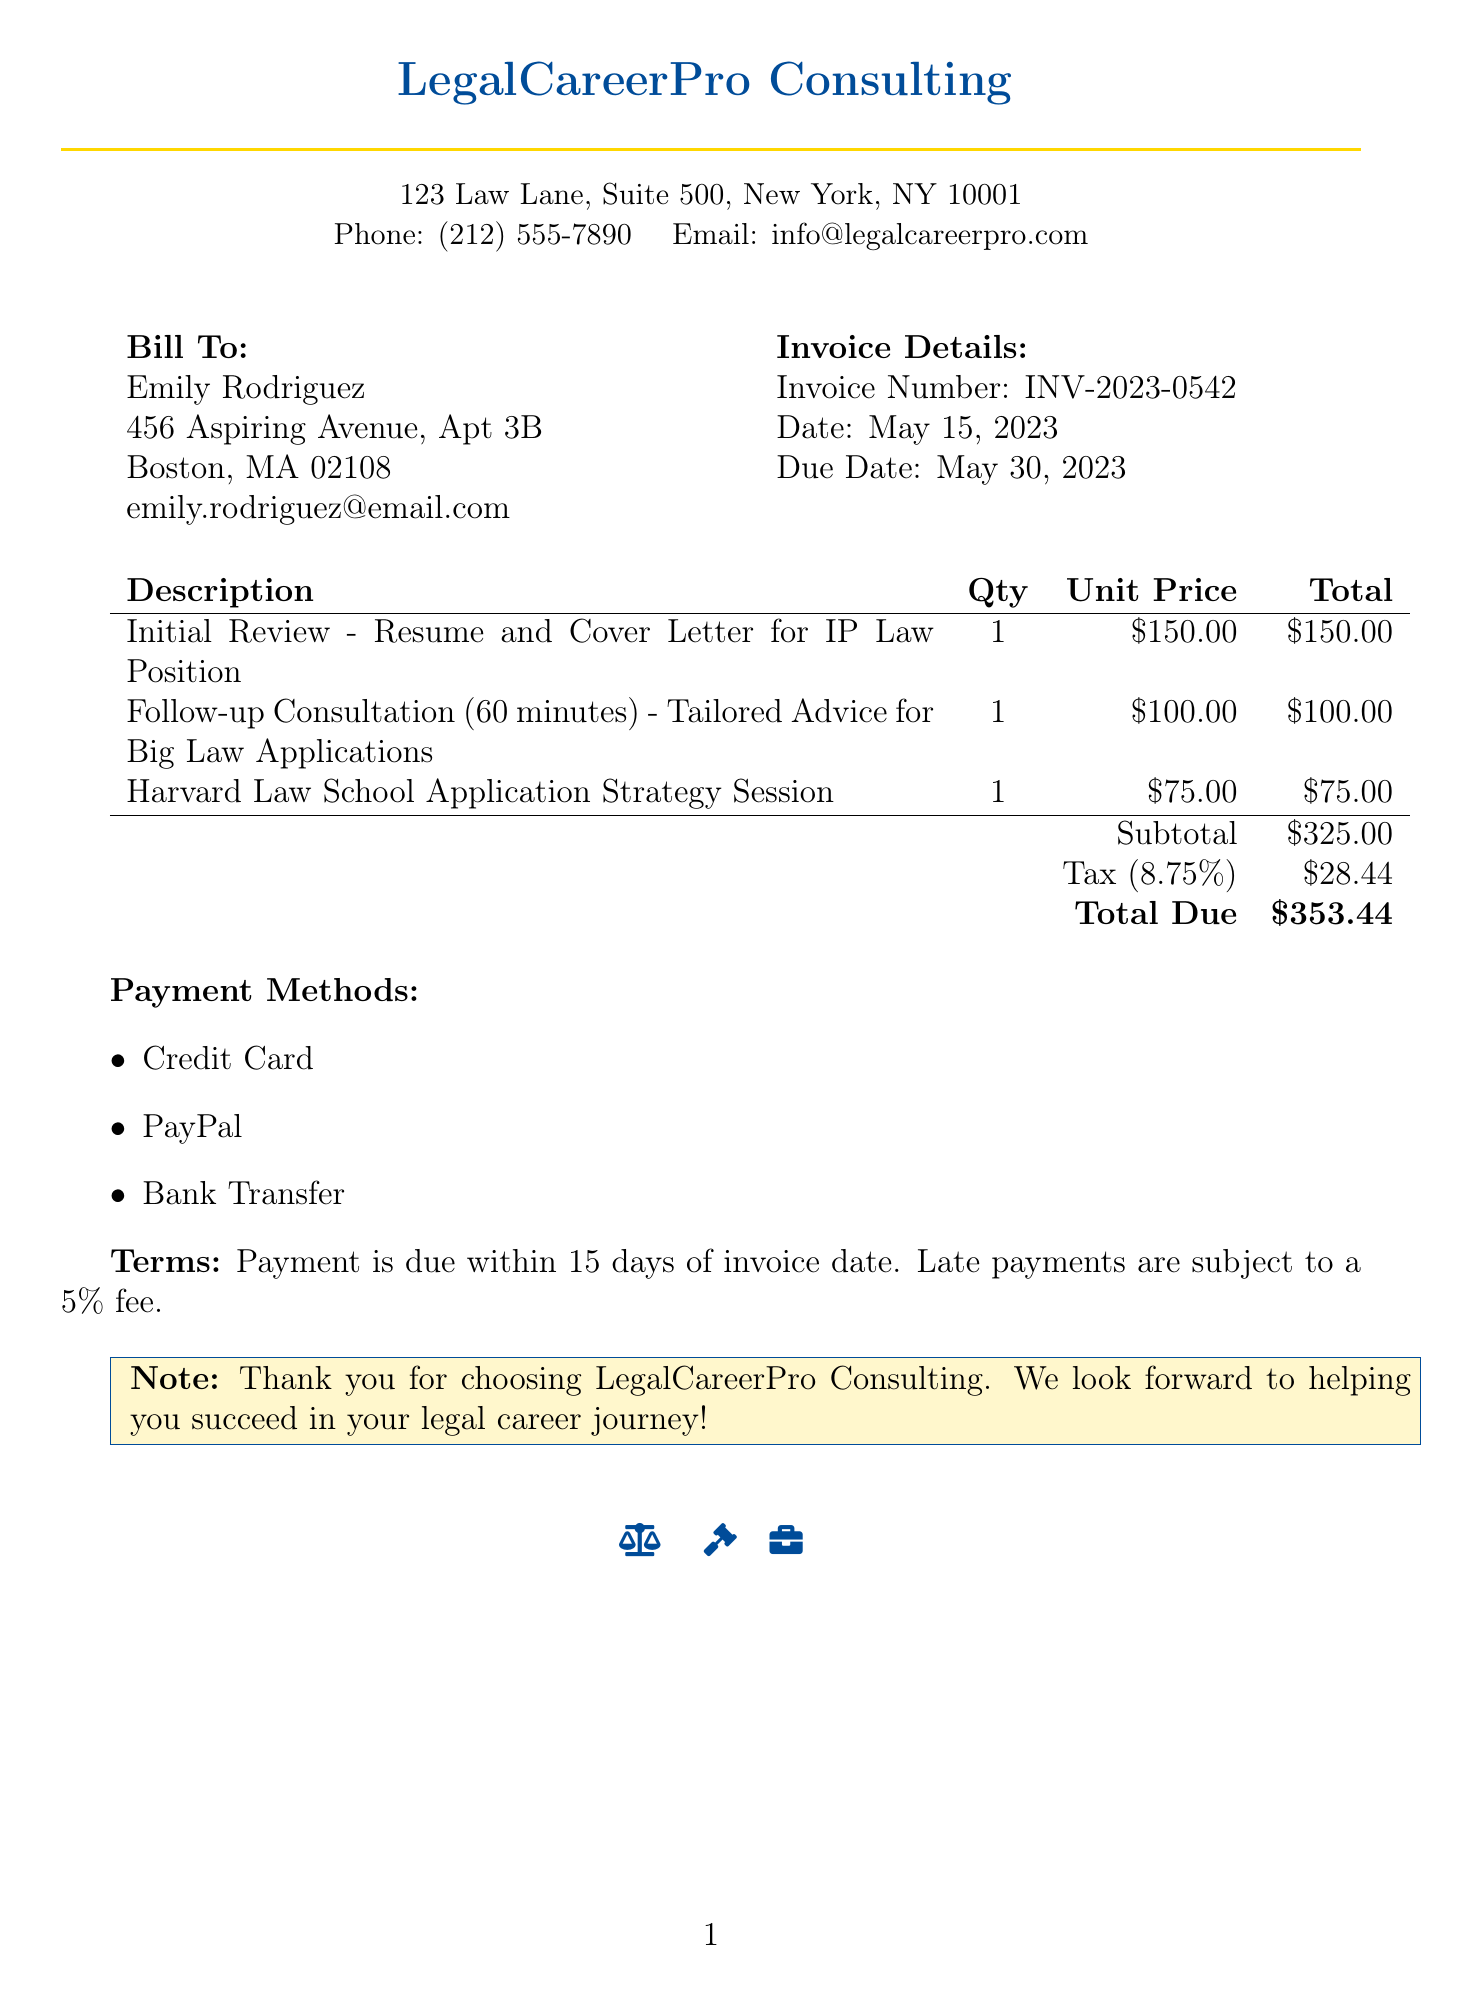What is the invoice number? The invoice number is listed under the invoice details section of the document.
Answer: INV-2023-0542 What is the date of the invoice? The date of the invoice is provided in the invoice details section.
Answer: May 15, 2023 Who is the service provider? The service provider's name is found at the top section of the document.
Answer: LegalCareerPro Consulting How much is charged for the follow-up consultation? The amount charged for the follow-up consultation is detailed in the services section.
Answer: 100.00 What is the subtotal before tax? The subtotal is specified in the breakdown of costs within the invoice.
Answer: 325.00 What is the due date for the payment? The due date is mentioned in the invoice details section of the document.
Answer: May 30, 2023 What is the tax rate applied to the invoice? The tax rate is indicated in the tax calculation part of the document.
Answer: 8.75% What is the total amount due? The total amount due is provided at the bottom of the payment calculation section.
Answer: 353.44 What payment methods are accepted? The accepted payment methods are listed in the additional information area of the document.
Answer: Credit Card, PayPal, Bank Transfer 